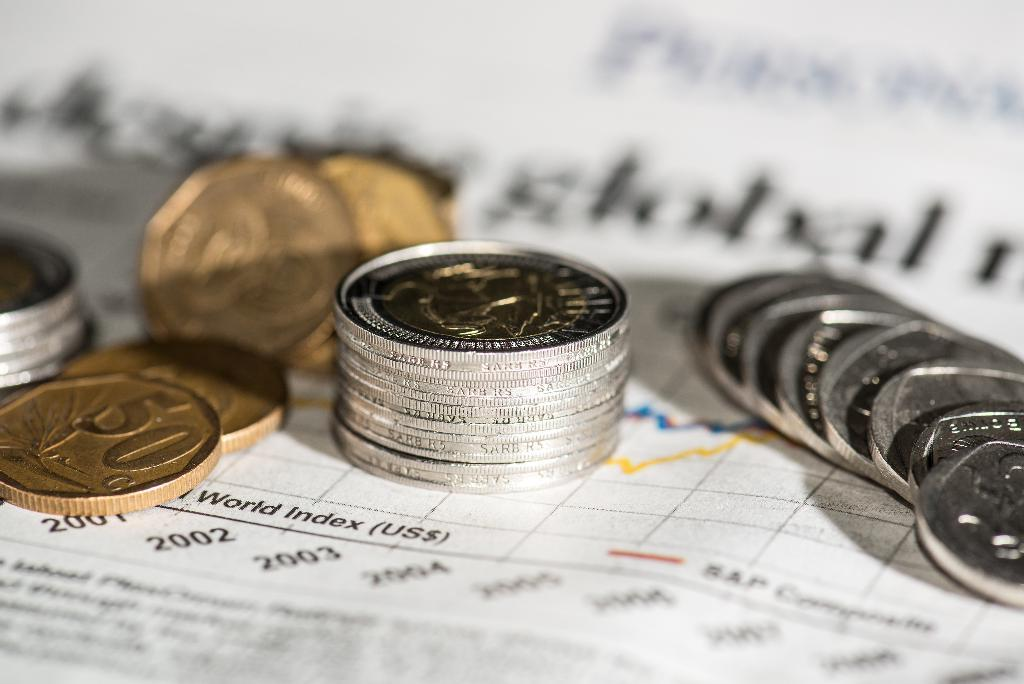<image>
Offer a succinct explanation of the picture presented. Several coins are stacked on top of a financial report with a graph. 